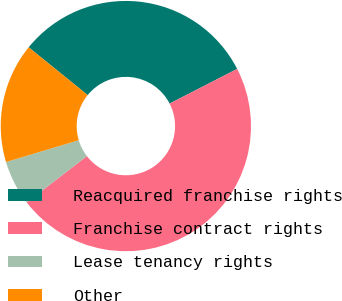<chart> <loc_0><loc_0><loc_500><loc_500><pie_chart><fcel>Reacquired franchise rights<fcel>Franchise contract rights<fcel>Lease tenancy rights<fcel>Other<nl><fcel>31.61%<fcel>47.1%<fcel>5.81%<fcel>15.48%<nl></chart> 